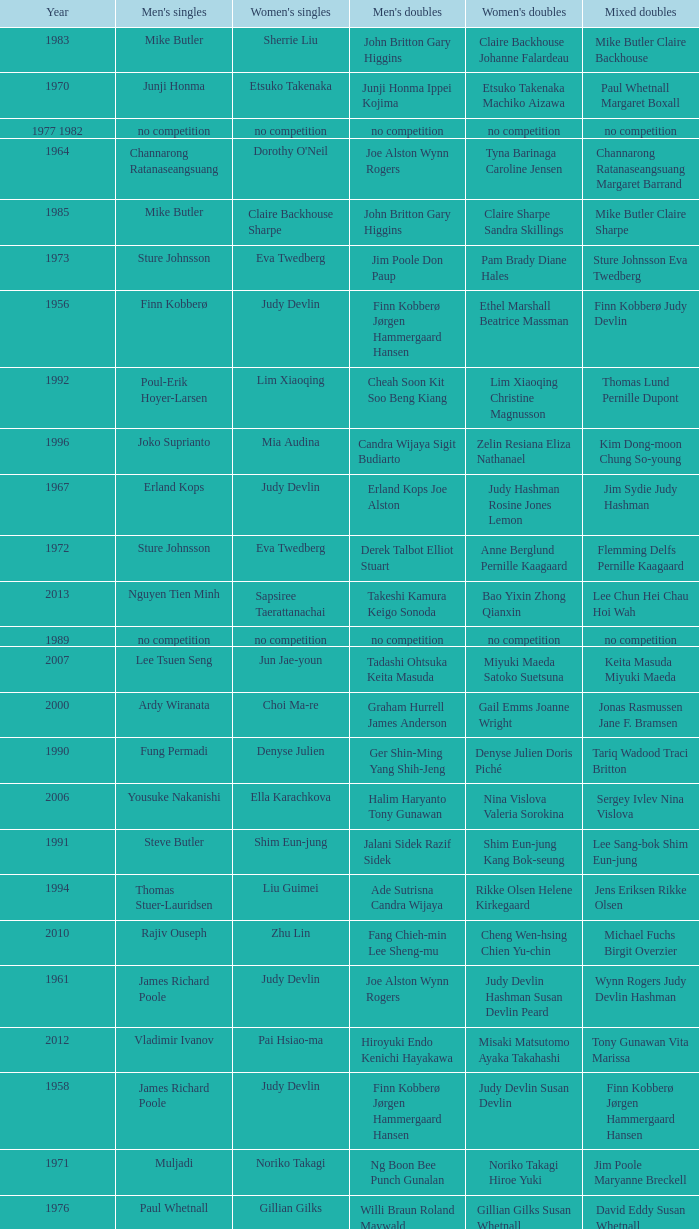Who were the men's doubles champions when the men's singles champion was muljadi? Ng Boon Bee Punch Gunalan. 